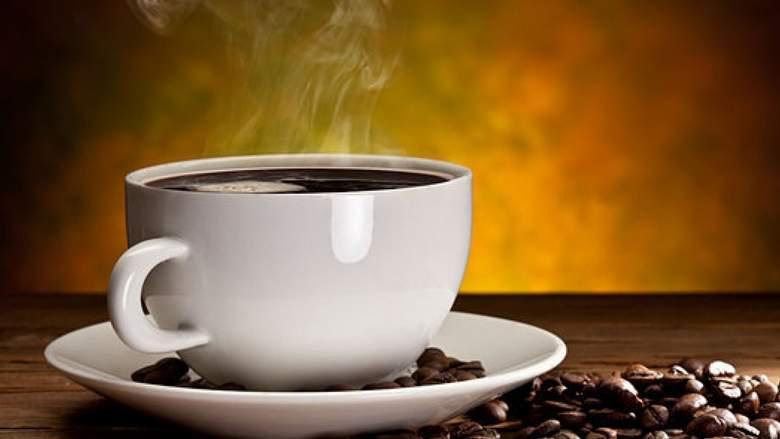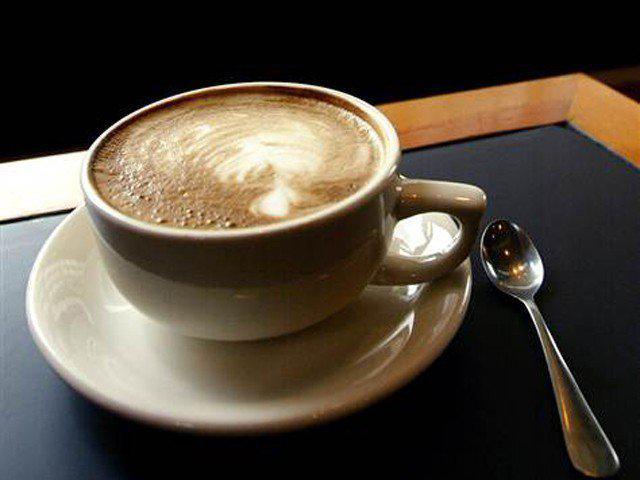The first image is the image on the left, the second image is the image on the right. Examine the images to the left and right. Is the description "There are three or more cups with coffee in them." accurate? Answer yes or no. No. The first image is the image on the left, the second image is the image on the right. Assess this claim about the two images: "There are no more than two cups of coffee.". Correct or not? Answer yes or no. Yes. 